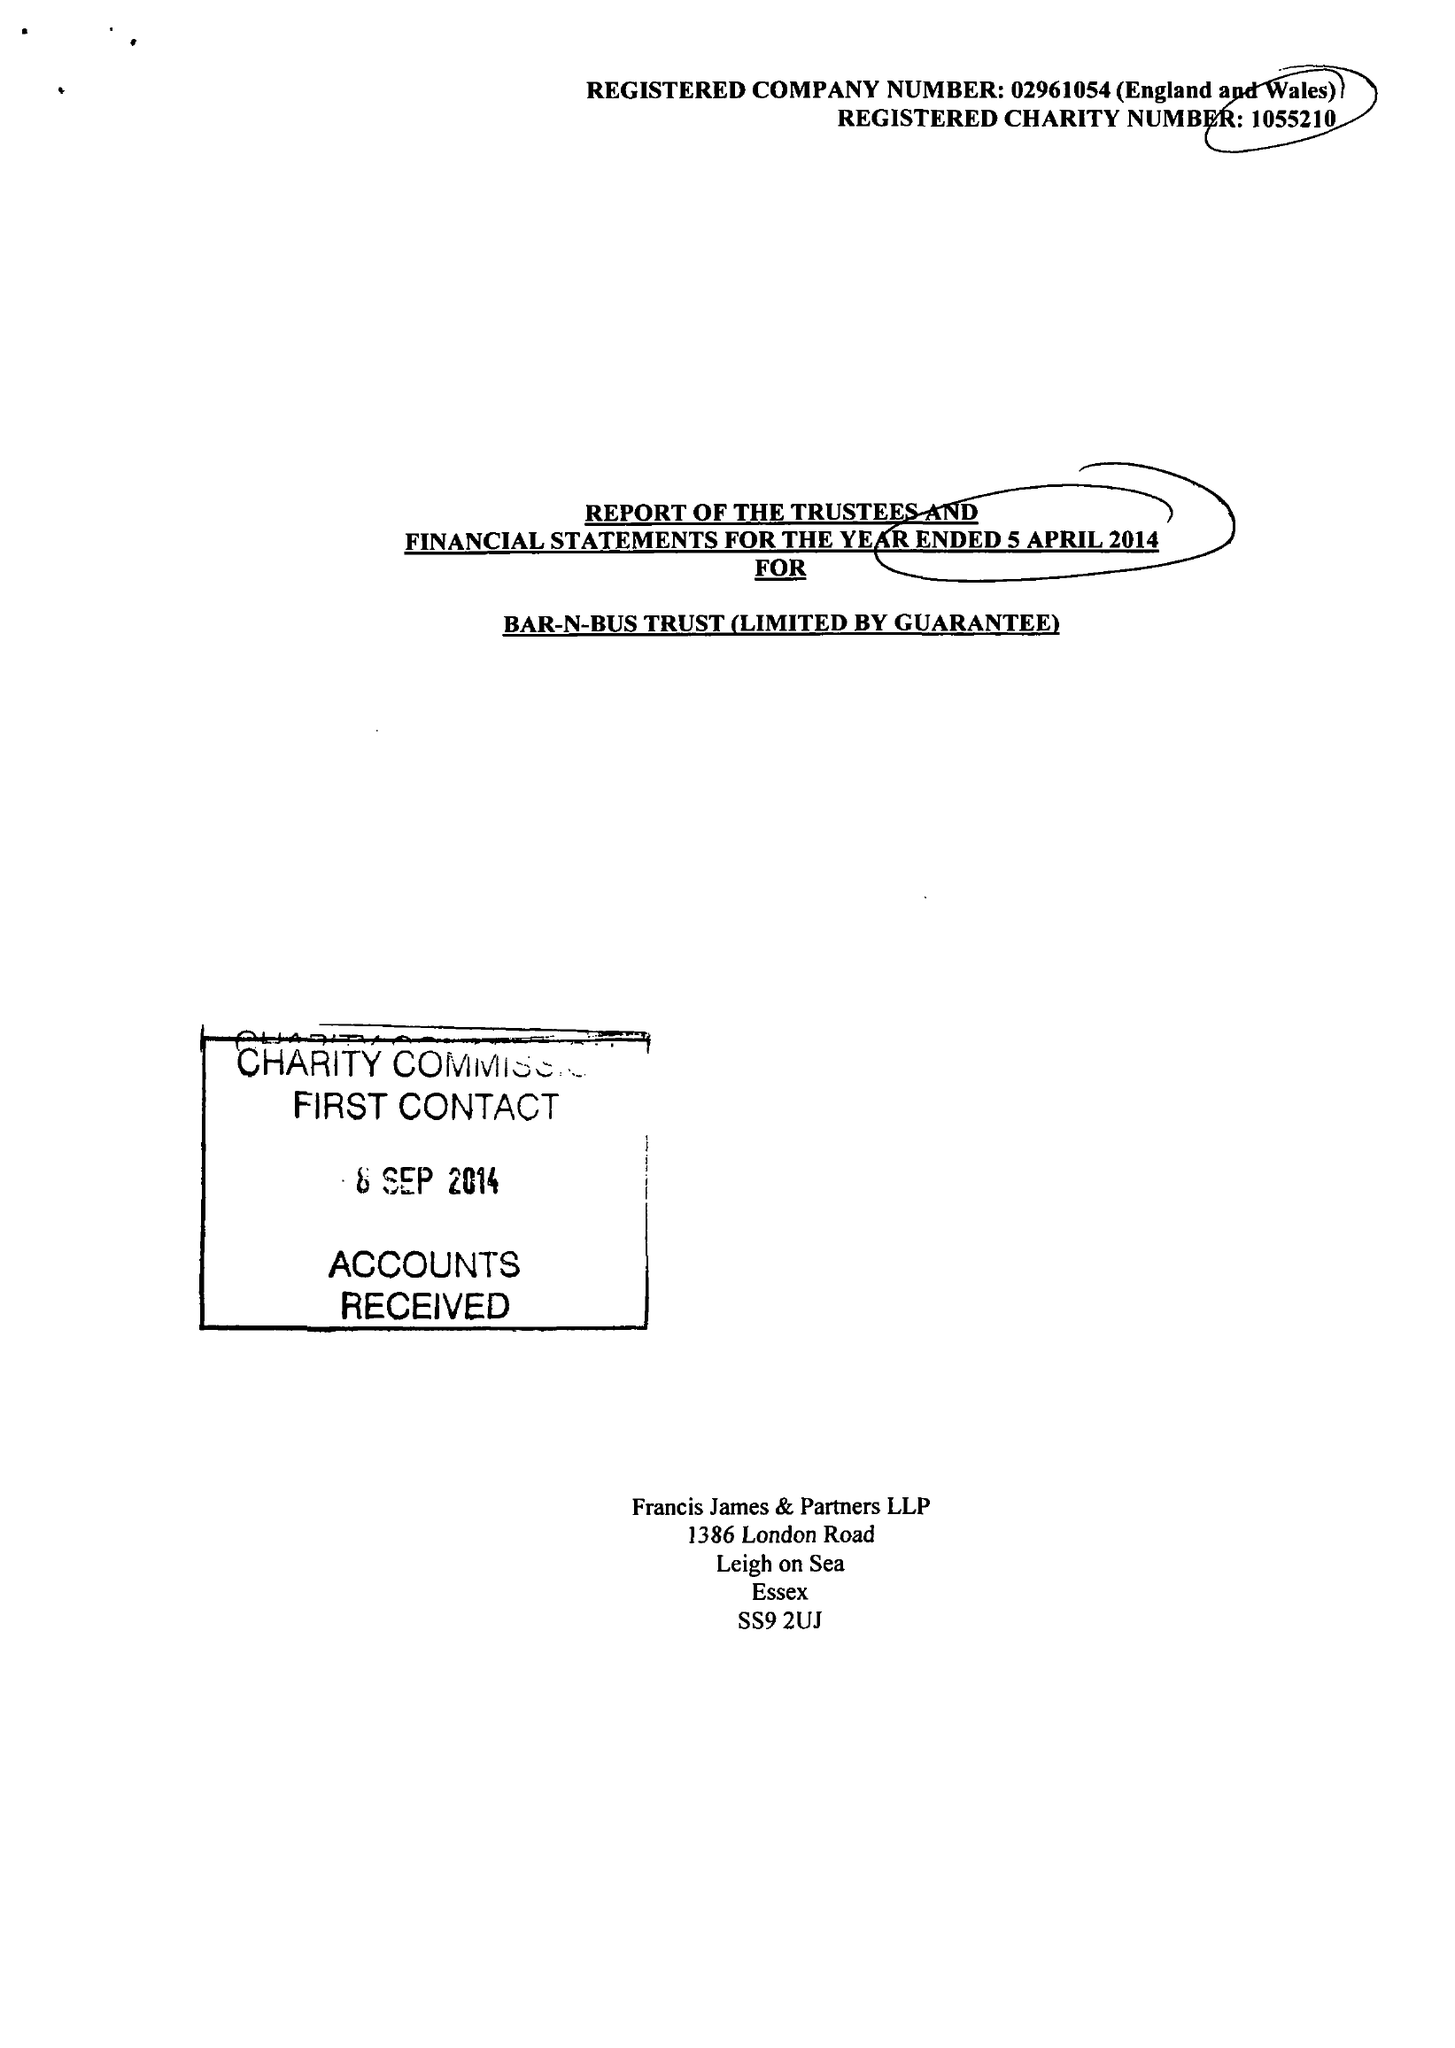What is the value for the charity_name?
Answer the question using a single word or phrase. Bar-N-Bus Trust 